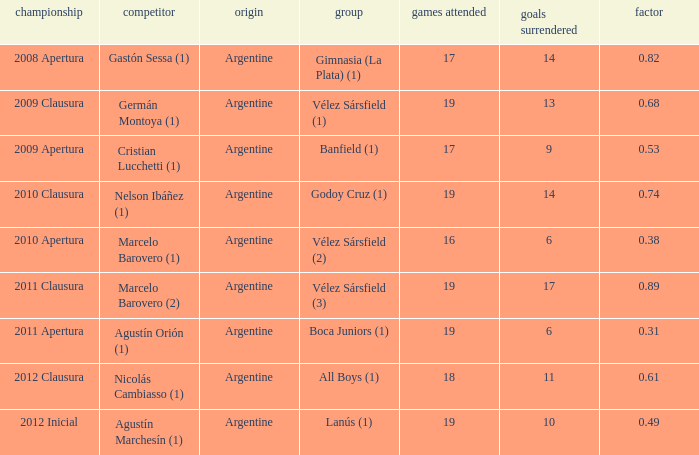How many nationalities are there for the 2011 apertura? 1.0. 